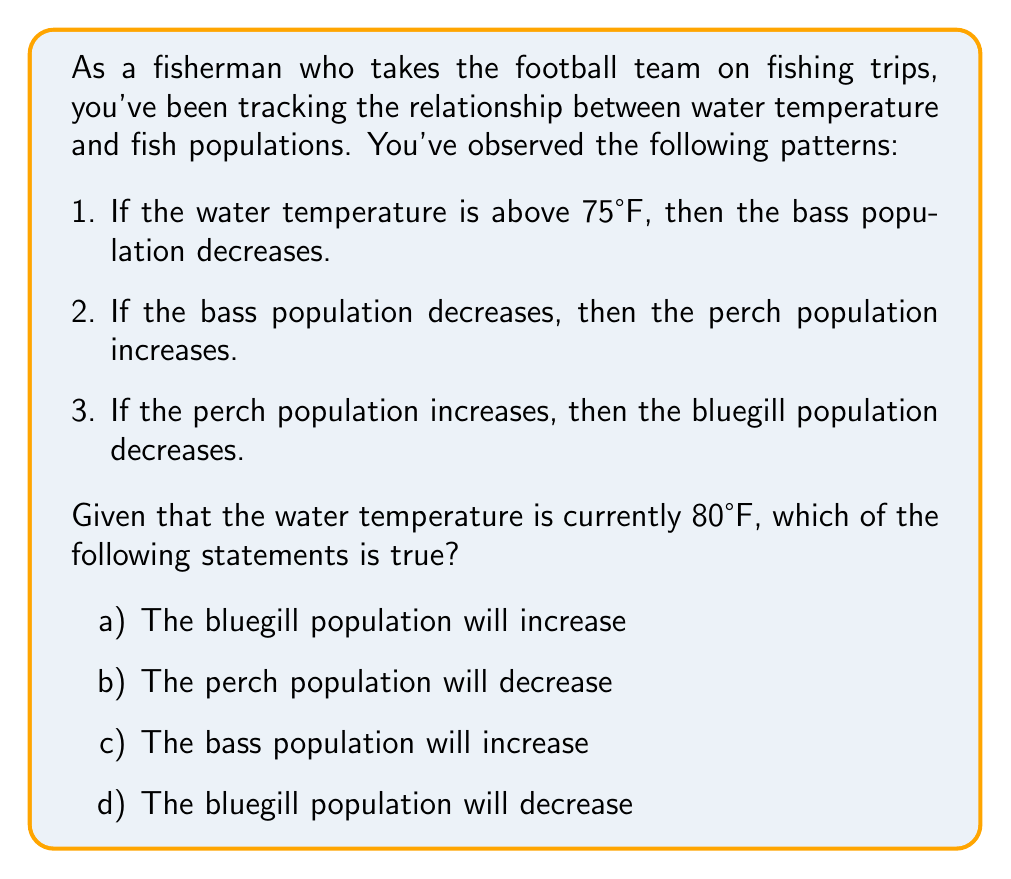Teach me how to tackle this problem. Let's analyze this problem using if-then statements and logical reasoning:

1. We start with the given information: The water temperature is 80°F.

2. Using the first statement: 
   If temperature > 75°F, then bass population decreases.
   Since 80°F > 75°F, we can conclude that the bass population decreases.

3. Using the second statement:
   If bass population decreases, then perch population increases.
   We know from step 2 that the bass population decreases, so we can conclude that the perch population increases.

4. Using the third statement:
   If perch population increases, then bluegill population decreases.
   We know from step 3 that the perch population increases, so we can conclude that the bluegill population decreases.

Now, let's evaluate each option:

a) The bluegill population will increase - False, we concluded it decreases.
b) The perch population will decrease - False, we concluded it increases.
c) The bass population will increase - False, we concluded it decreases.
d) The bluegill population will decrease - True, this matches our conclusion.

Therefore, the correct answer is option d.

This problem demonstrates the use of if-then statements and logical chains in analyzing ecological relationships, which is relevant to both fishing and team-building activities.
Answer: d) The bluegill population will decrease 